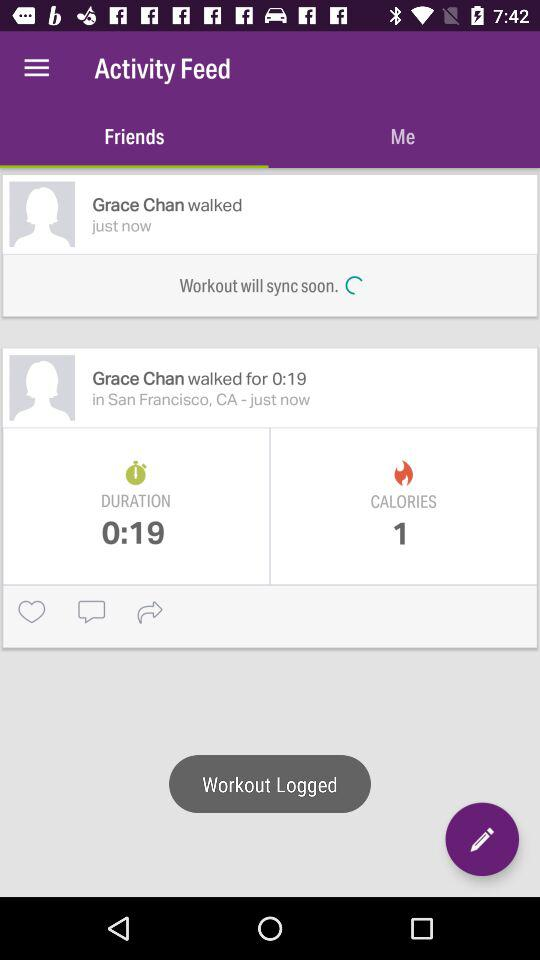How many calories did Grace Chan burn?
Answer the question using a single word or phrase. 1 